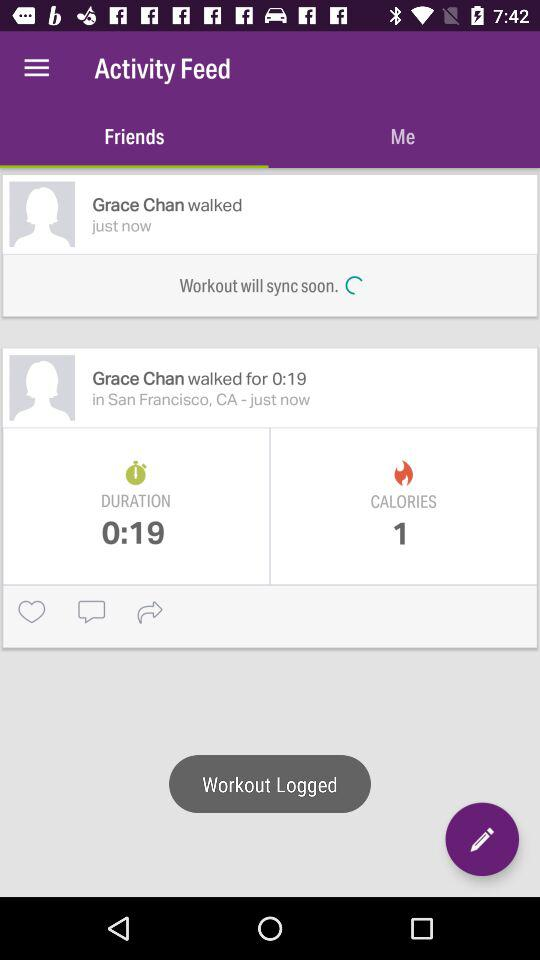How many calories did Grace Chan burn?
Answer the question using a single word or phrase. 1 